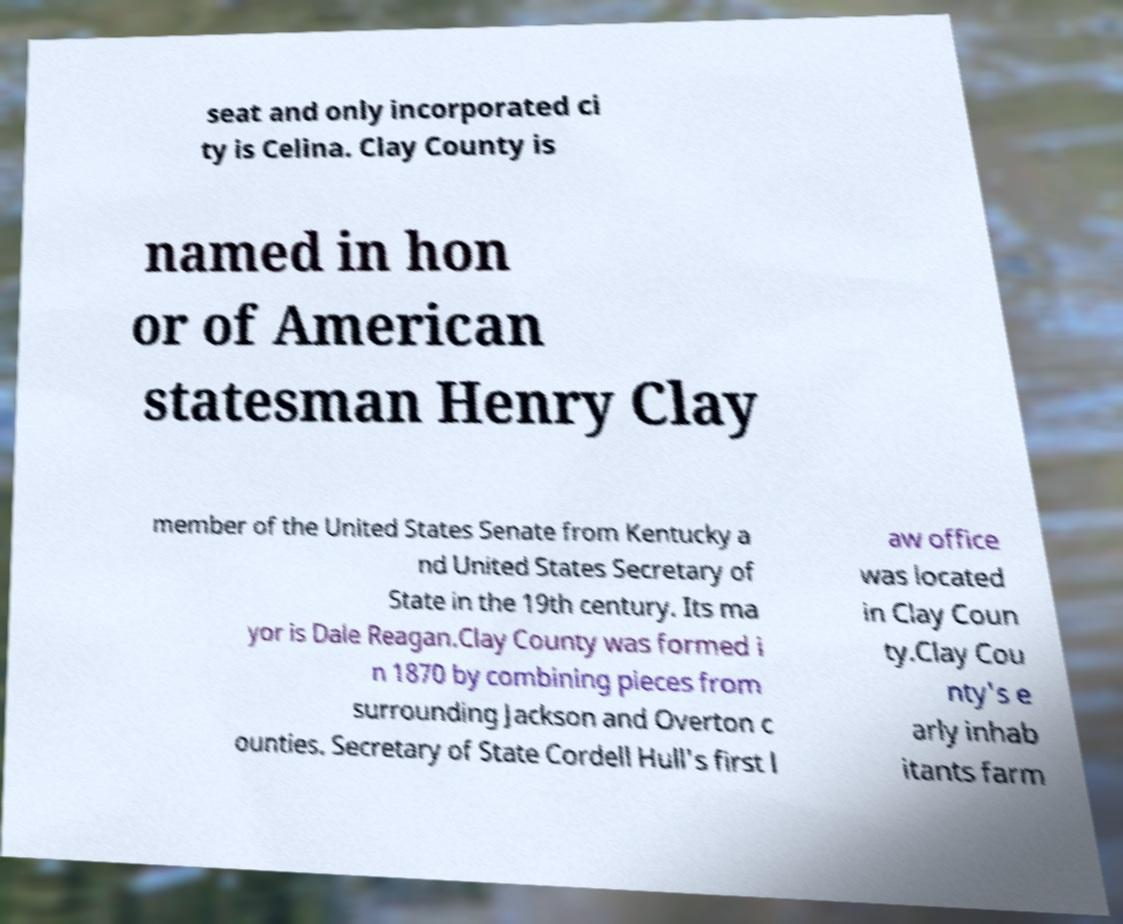Could you assist in decoding the text presented in this image and type it out clearly? seat and only incorporated ci ty is Celina. Clay County is named in hon or of American statesman Henry Clay member of the United States Senate from Kentucky a nd United States Secretary of State in the 19th century. Its ma yor is Dale Reagan.Clay County was formed i n 1870 by combining pieces from surrounding Jackson and Overton c ounties. Secretary of State Cordell Hull's first l aw office was located in Clay Coun ty.Clay Cou nty's e arly inhab itants farm 